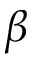<formula> <loc_0><loc_0><loc_500><loc_500>\beta</formula> 